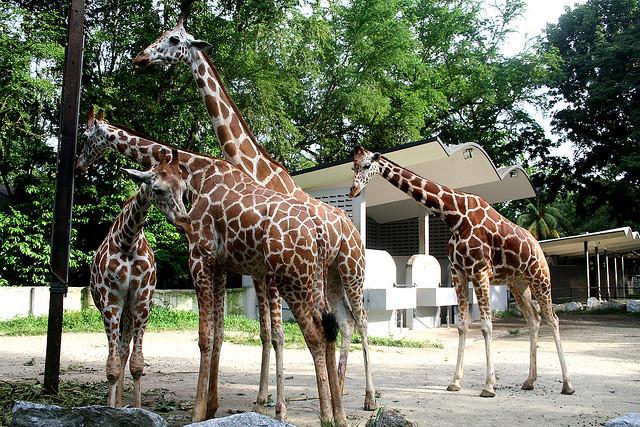Are they in a zoo?
Write a very short answer. Yes. Are all the giraffes the same height?
Quick response, please. No. How many animals are standing around?
Answer briefly. 4. Are there more than two giraffe in this picture?
Give a very brief answer. Yes. How many animals do you see?
Keep it brief. 4. 